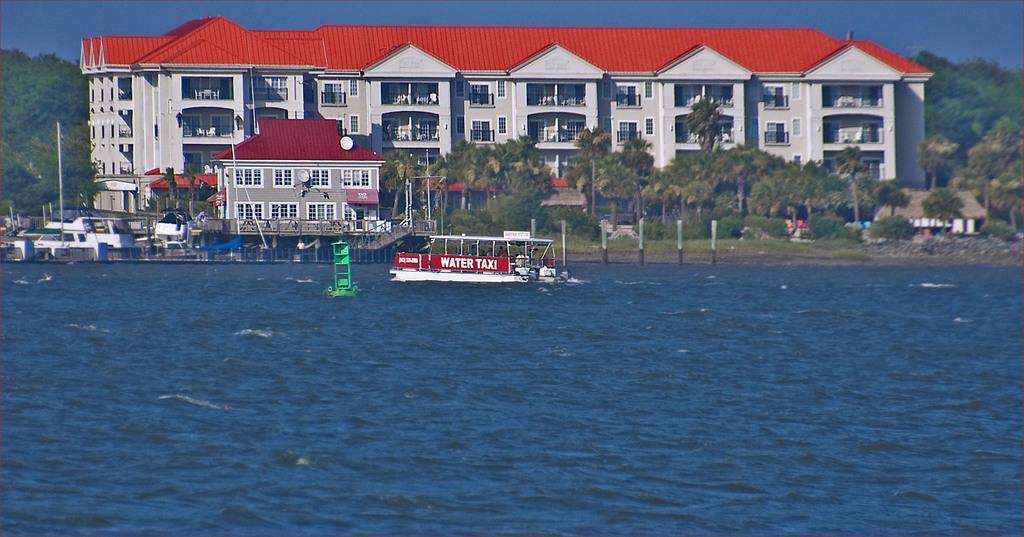How would you summarize this image in a sentence or two? In this image, we can see a boat on the water and in the background, there are buildings, trees, poles, stairs and some sheds and some other benches. At the top, there is sky. 